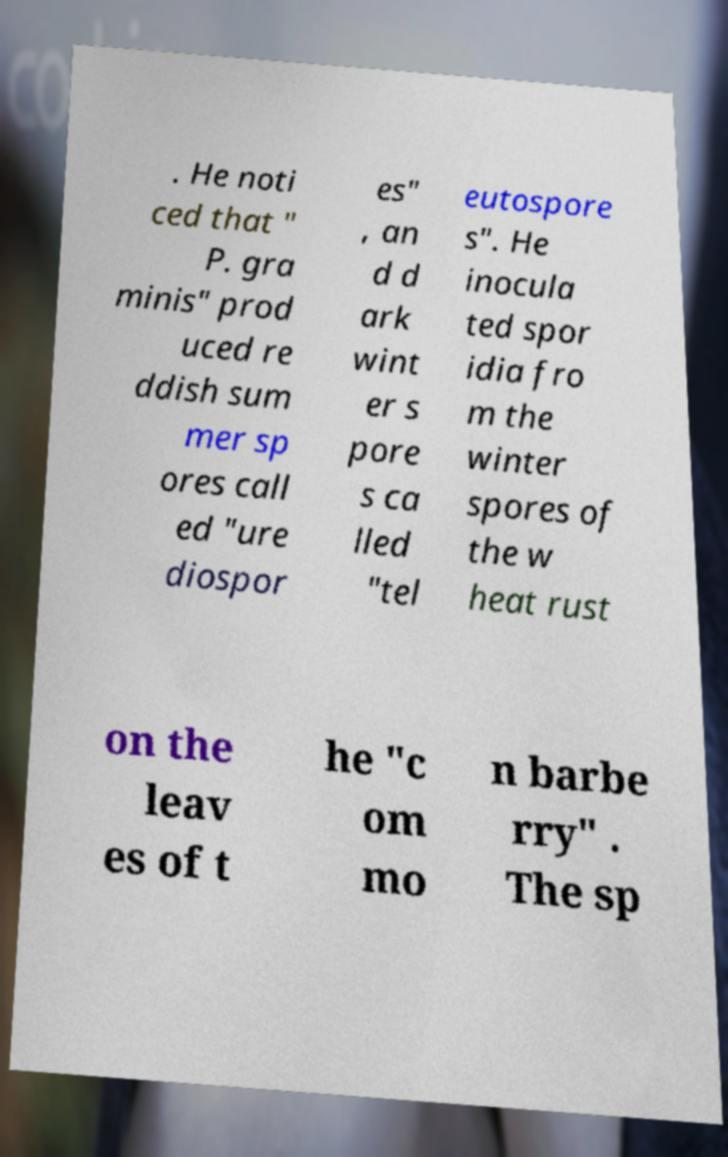There's text embedded in this image that I need extracted. Can you transcribe it verbatim? . He noti ced that " P. gra minis" prod uced re ddish sum mer sp ores call ed "ure diospor es" , an d d ark wint er s pore s ca lled "tel eutospore s". He inocula ted spor idia fro m the winter spores of the w heat rust on the leav es of t he "c om mo n barbe rry" . The sp 